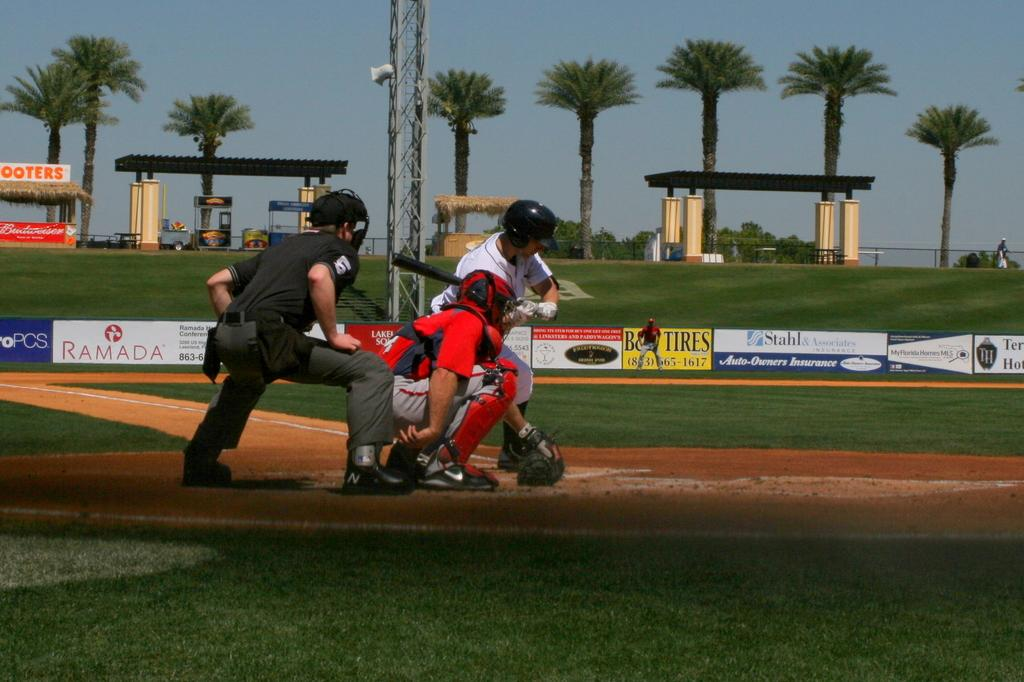How many people can be seen in the image? There are people in the image, but the exact number is not specified. What is the person holding in the image? One person is holding something, but the specific object is not mentioned. What type of structures can be seen in the background of the image? There are sheds, pillars, a hut, and different boards visible in the background. What is the natural environment visible in the background of the image? Trees and the sky are visible in the background of the image. What additional feature can be seen in the background of the image? There is a banner and a pole in the background of the image. How many bridges are visible in the image? There are no bridges visible in the image. What type of fire can be seen in the image? There is no fire present in the image. 